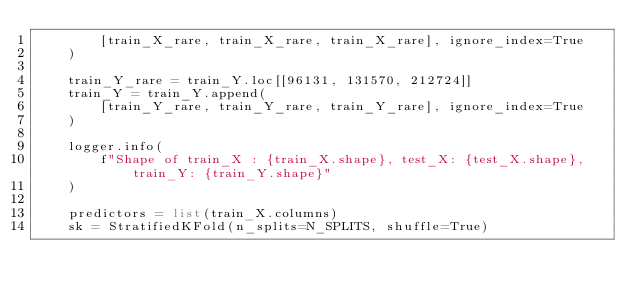<code> <loc_0><loc_0><loc_500><loc_500><_Python_>        [train_X_rare, train_X_rare, train_X_rare], ignore_index=True
    )

    train_Y_rare = train_Y.loc[[96131, 131570, 212724]]
    train_Y = train_Y.append(
        [train_Y_rare, train_Y_rare, train_Y_rare], ignore_index=True
    )

    logger.info(
        f"Shape of train_X : {train_X.shape}, test_X: {test_X.shape}, train_Y: {train_Y.shape}"
    )

    predictors = list(train_X.columns)
    sk = StratifiedKFold(n_splits=N_SPLITS, shuffle=True)
</code> 